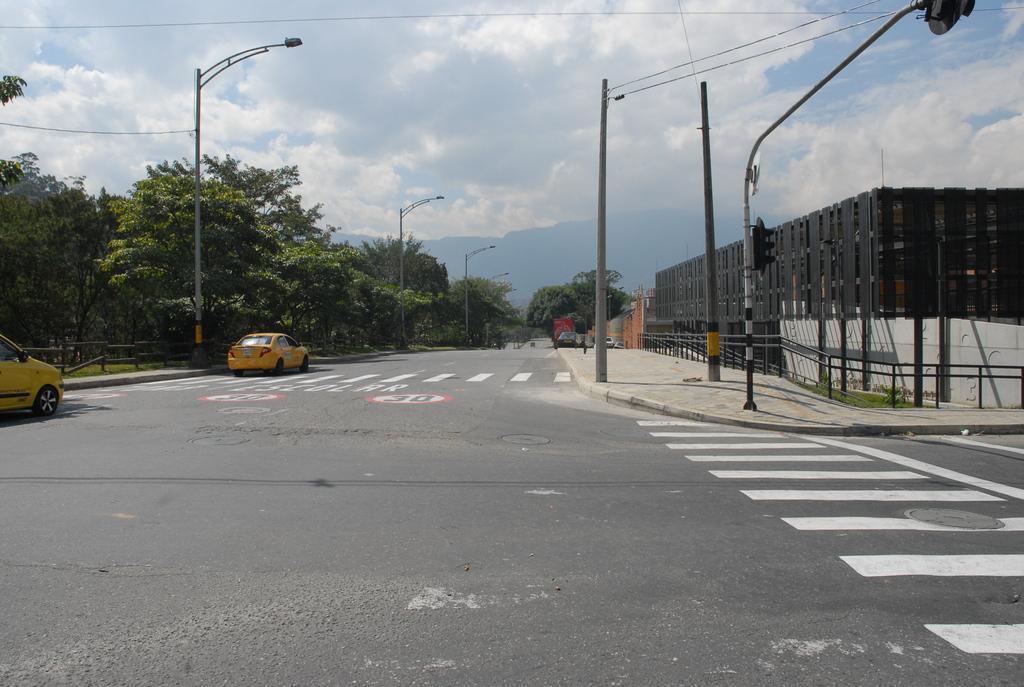Can you describe this image briefly? In this image there is the sky truncated towards the top of the image, there are clouds in the sky, there are trees, there are trees truncated towards the left of the image, there is road truncated towards the bottom of the image, there are vehicles on the road, there is a vehicle truncated towards the left of the image, there are poles, there are wires truncated, there is a fencing truncated towards the right of the image, there is a wall truncated towards the right of the image, there is a board truncated towards the top of the image. 